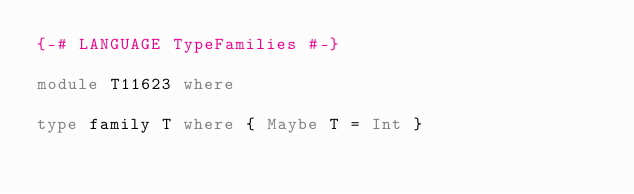Convert code to text. <code><loc_0><loc_0><loc_500><loc_500><_Haskell_>{-# LANGUAGE TypeFamilies #-}

module T11623 where

type family T where { Maybe T = Int }
</code> 